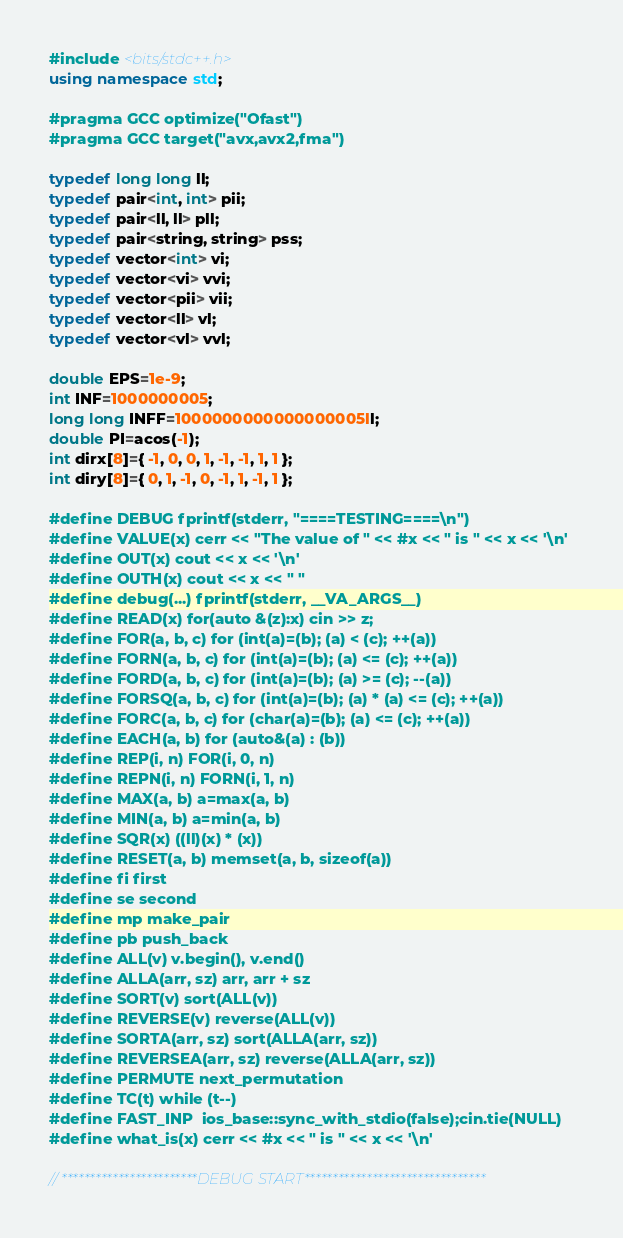<code> <loc_0><loc_0><loc_500><loc_500><_C++_>#include <bits/stdc++.h>
using namespace std;

#pragma GCC optimize("Ofast")
#pragma GCC target("avx,avx2,fma")

typedef long long ll;
typedef pair<int, int> pii;
typedef pair<ll, ll> pll;
typedef pair<string, string> pss;
typedef vector<int> vi;
typedef vector<vi> vvi;
typedef vector<pii> vii;
typedef vector<ll> vl;
typedef vector<vl> vvl;

double EPS=1e-9;
int INF=1000000005;
long long INFF=1000000000000000005ll;
double PI=acos(-1);
int dirx[8]={ -1, 0, 0, 1, -1, -1, 1, 1 };
int diry[8]={ 0, 1, -1, 0, -1, 1, -1, 1 };

#define DEBUG fprintf(stderr, "====TESTING====\n")
#define VALUE(x) cerr << "The value of " << #x << " is " << x << '\n'
#define OUT(x) cout << x << '\n'
#define OUTH(x) cout << x << " "
#define debug(...) fprintf(stderr, __VA_ARGS__)
#define READ(x) for(auto &(z):x) cin >> z;
#define FOR(a, b, c) for (int(a)=(b); (a) < (c); ++(a))
#define FORN(a, b, c) for (int(a)=(b); (a) <= (c); ++(a))
#define FORD(a, b, c) for (int(a)=(b); (a) >= (c); --(a))
#define FORSQ(a, b, c) for (int(a)=(b); (a) * (a) <= (c); ++(a))
#define FORC(a, b, c) for (char(a)=(b); (a) <= (c); ++(a))
#define EACH(a, b) for (auto&(a) : (b))
#define REP(i, n) FOR(i, 0, n)
#define REPN(i, n) FORN(i, 1, n)
#define MAX(a, b) a=max(a, b)
#define MIN(a, b) a=min(a, b)
#define SQR(x) ((ll)(x) * (x))
#define RESET(a, b) memset(a, b, sizeof(a))
#define fi first
#define se second
#define mp make_pair
#define pb push_back
#define ALL(v) v.begin(), v.end()
#define ALLA(arr, sz) arr, arr + sz
#define SORT(v) sort(ALL(v))
#define REVERSE(v) reverse(ALL(v))
#define SORTA(arr, sz) sort(ALLA(arr, sz))
#define REVERSEA(arr, sz) reverse(ALLA(arr, sz))
#define PERMUTE next_permutation
#define TC(t) while (t--)
#define FAST_INP  ios_base::sync_with_stdio(false);cin.tie(NULL)
#define what_is(x) cerr << #x << " is " << x << '\n'

// ************************DEBUG START********************************</code> 